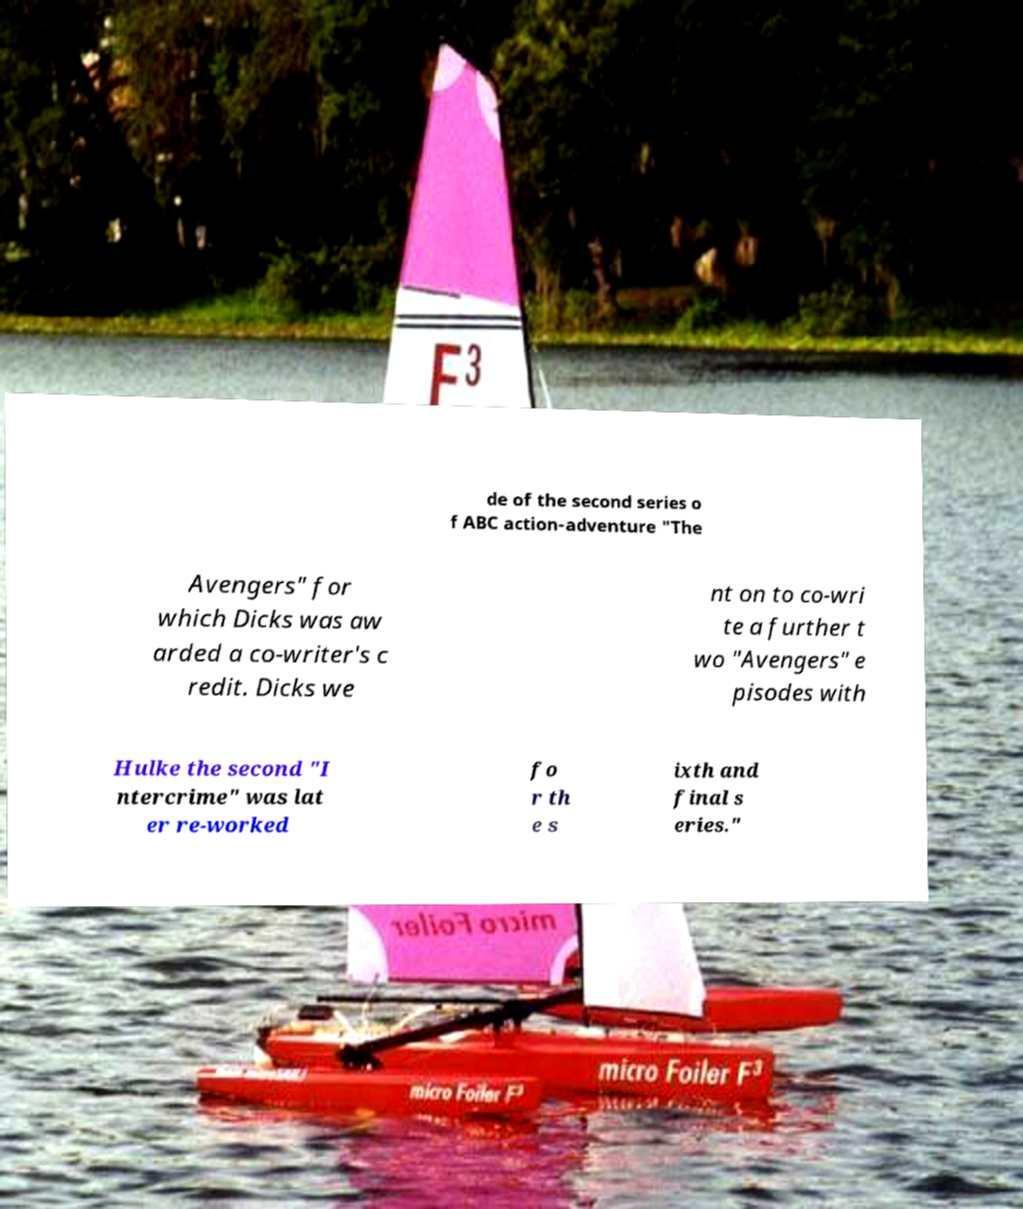Please identify and transcribe the text found in this image. de of the second series o f ABC action-adventure "The Avengers" for which Dicks was aw arded a co-writer's c redit. Dicks we nt on to co-wri te a further t wo "Avengers" e pisodes with Hulke the second "I ntercrime" was lat er re-worked fo r th e s ixth and final s eries." 